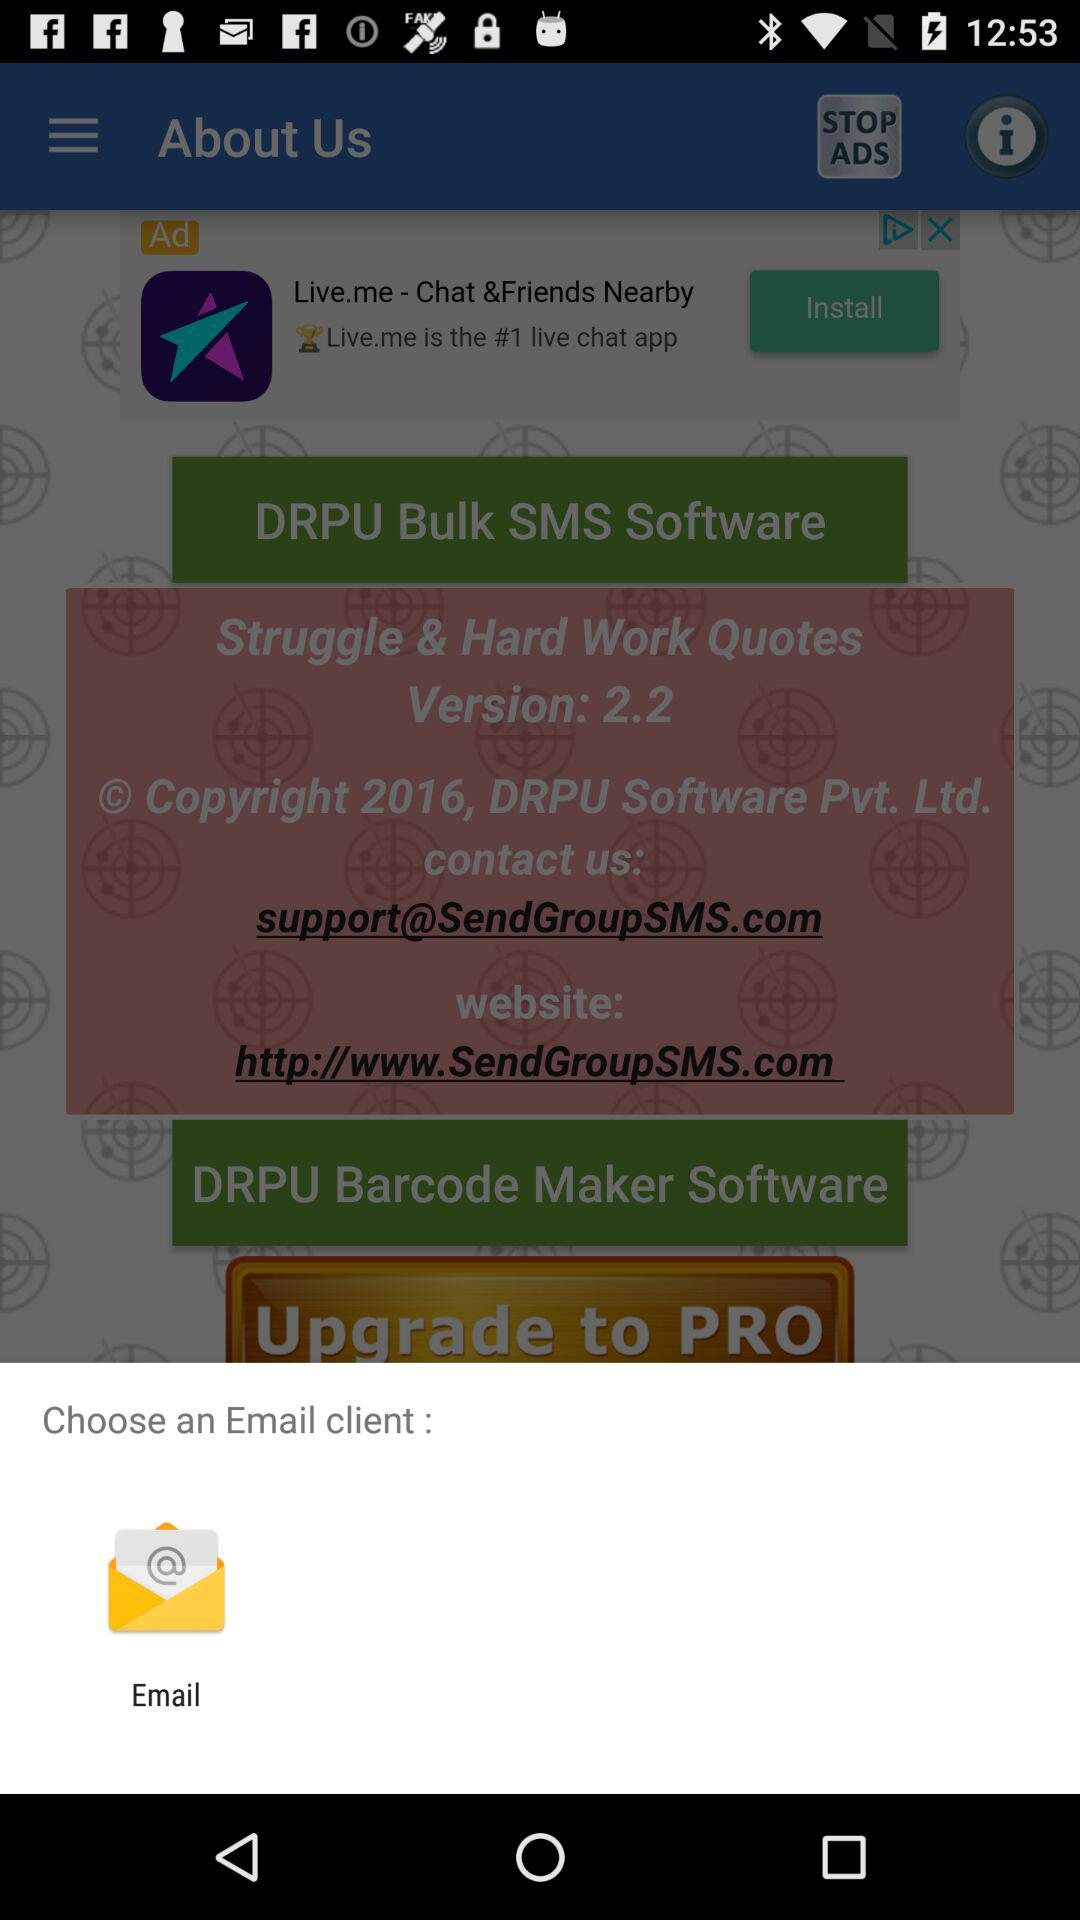What is the software name? The software names are "DRPU Bulk SMS" and "DRPU Barcode Maker". 